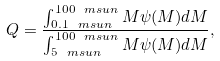Convert formula to latex. <formula><loc_0><loc_0><loc_500><loc_500>Q = \frac { \int _ { 0 . 1 \ m s u n } ^ { 1 0 0 \ m s u n } M \psi ( M ) d M } { \int _ { 5 \ m s u n } ^ { 1 0 0 \ m s u n } M \psi ( M ) d M } ,</formula> 